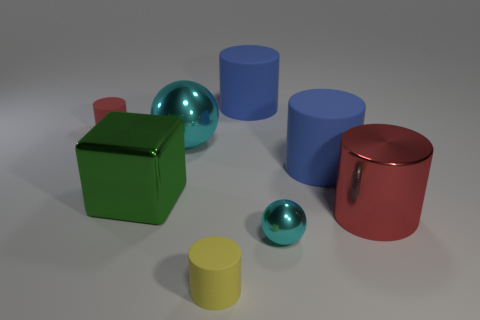Subtract all big red metallic cylinders. How many cylinders are left? 4 Add 1 big purple metallic cylinders. How many objects exist? 9 Subtract all yellow cylinders. How many cylinders are left? 4 Subtract all cylinders. How many objects are left? 3 Subtract 1 cylinders. How many cylinders are left? 4 Add 8 tiny balls. How many tiny balls are left? 9 Add 1 green rubber cylinders. How many green rubber cylinders exist? 1 Subtract 0 cyan blocks. How many objects are left? 8 Subtract all gray spheres. Subtract all purple cubes. How many spheres are left? 2 Subtract all cyan blocks. How many yellow cylinders are left? 1 